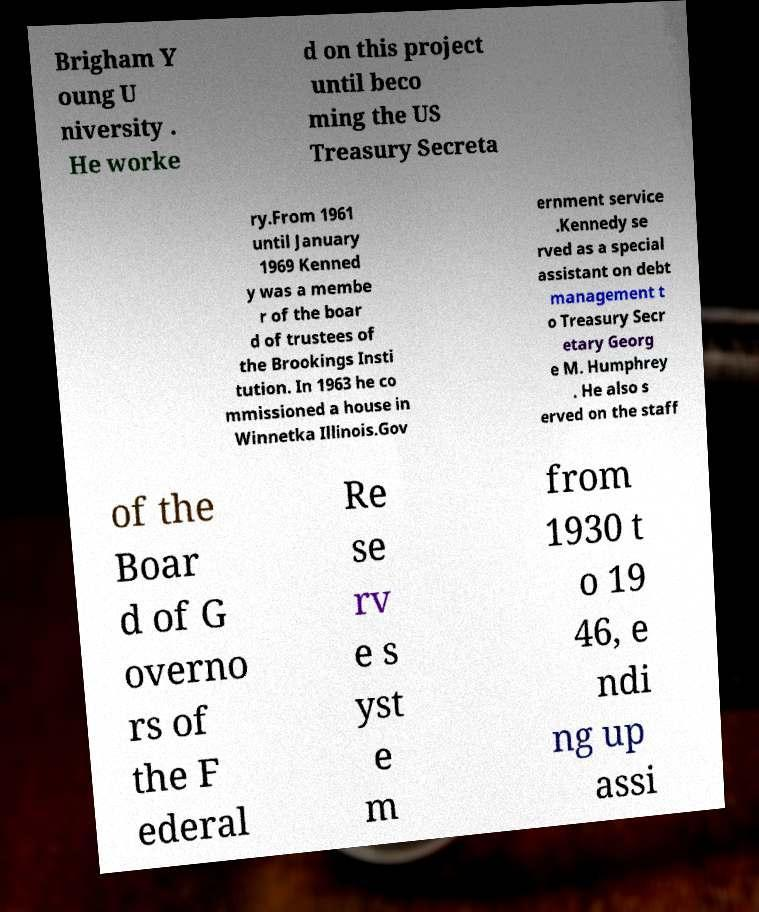Can you read and provide the text displayed in the image?This photo seems to have some interesting text. Can you extract and type it out for me? Brigham Y oung U niversity . He worke d on this project until beco ming the US Treasury Secreta ry.From 1961 until January 1969 Kenned y was a membe r of the boar d of trustees of the Brookings Insti tution. In 1963 he co mmissioned a house in Winnetka Illinois.Gov ernment service .Kennedy se rved as a special assistant on debt management t o Treasury Secr etary Georg e M. Humphrey . He also s erved on the staff of the Boar d of G overno rs of the F ederal Re se rv e s yst e m from 1930 t o 19 46, e ndi ng up assi 